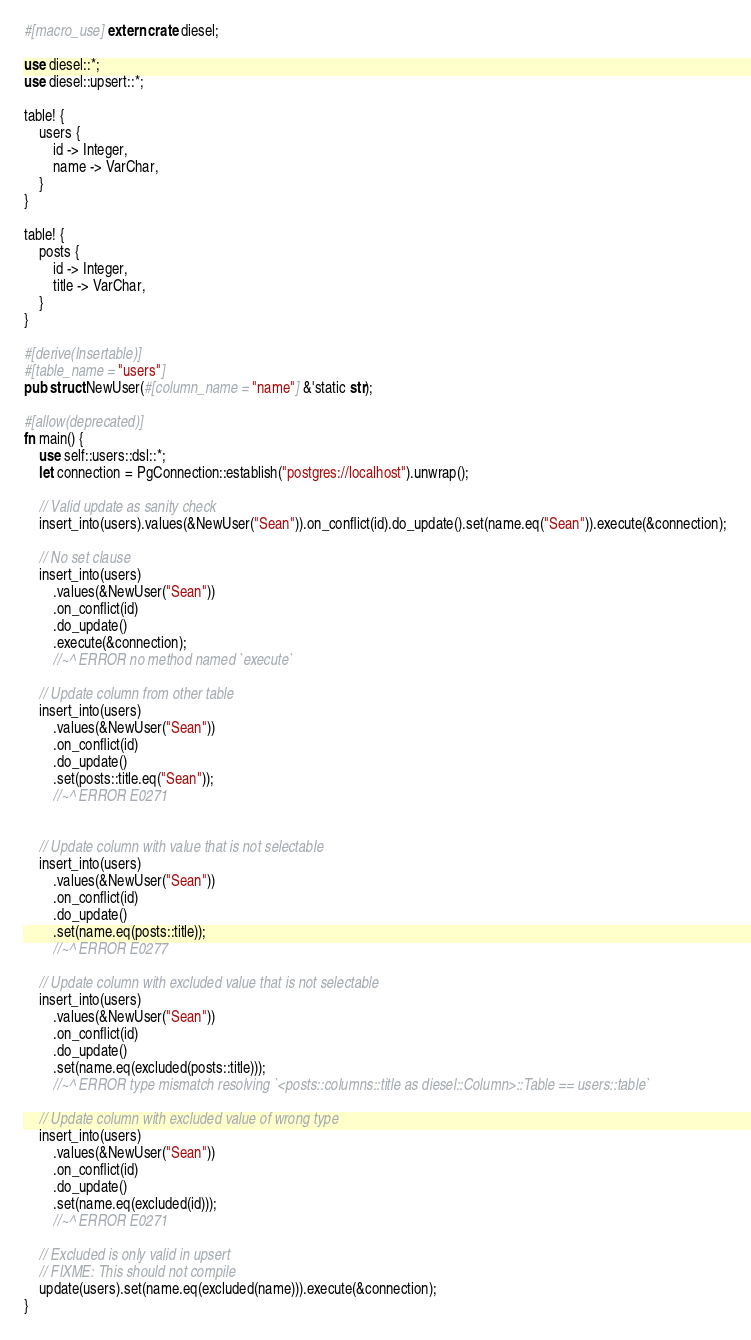Convert code to text. <code><loc_0><loc_0><loc_500><loc_500><_Rust_>#[macro_use] extern crate diesel;

use diesel::*;
use diesel::upsert::*;

table! {
    users {
        id -> Integer,
        name -> VarChar,
    }
}

table! {
    posts {
        id -> Integer,
        title -> VarChar,
    }
}

#[derive(Insertable)]
#[table_name = "users"]
pub struct NewUser(#[column_name = "name"] &'static str);

#[allow(deprecated)]
fn main() {
    use self::users::dsl::*;
    let connection = PgConnection::establish("postgres://localhost").unwrap();

    // Valid update as sanity check
    insert_into(users).values(&NewUser("Sean")).on_conflict(id).do_update().set(name.eq("Sean")).execute(&connection);

    // No set clause
    insert_into(users)
        .values(&NewUser("Sean"))
        .on_conflict(id)
        .do_update()
        .execute(&connection);
        //~^ ERROR no method named `execute`

    // Update column from other table
    insert_into(users)
        .values(&NewUser("Sean"))
        .on_conflict(id)
        .do_update()
        .set(posts::title.eq("Sean"));
        //~^ ERROR E0271


    // Update column with value that is not selectable
    insert_into(users)
        .values(&NewUser("Sean"))
        .on_conflict(id)
        .do_update()
        .set(name.eq(posts::title));
        //~^ ERROR E0277

    // Update column with excluded value that is not selectable
    insert_into(users)
        .values(&NewUser("Sean"))
        .on_conflict(id)
        .do_update()
        .set(name.eq(excluded(posts::title)));
        //~^ ERROR type mismatch resolving `<posts::columns::title as diesel::Column>::Table == users::table`

    // Update column with excluded value of wrong type
    insert_into(users)
        .values(&NewUser("Sean"))
        .on_conflict(id)
        .do_update()
        .set(name.eq(excluded(id)));
        //~^ ERROR E0271

    // Excluded is only valid in upsert
    // FIXME: This should not compile
    update(users).set(name.eq(excluded(name))).execute(&connection);
}
</code> 